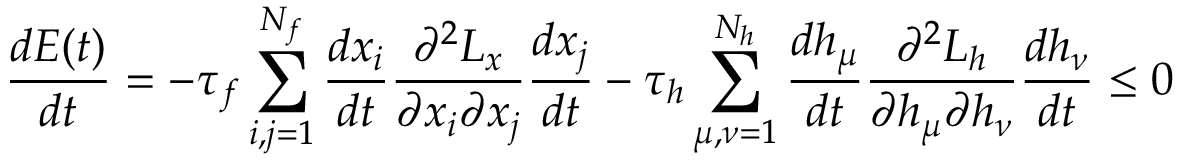<formula> <loc_0><loc_0><loc_500><loc_500>{ \frac { d E ( t ) } { d t } } = - \tau _ { f } \sum _ { i , j = 1 } ^ { N _ { f } } { \frac { d x _ { i } } { d t } } { \frac { \partial ^ { 2 } L _ { x } } { \partial x _ { i } \partial x _ { j } } } { \frac { d x _ { j } } { d t } } - \tau _ { h } \sum _ { \mu , \nu = 1 } ^ { N _ { h } } { \frac { d h _ { \mu } } { d t } } { \frac { \partial ^ { 2 } L _ { h } } { \partial h _ { \mu } \partial h _ { \nu } } } { \frac { d h _ { \nu } } { d t } } \leq 0</formula> 